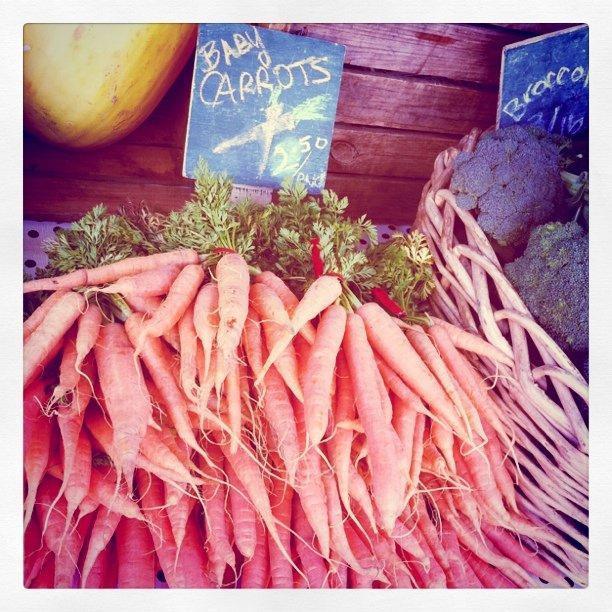How many broccolis are in the picture?
Give a very brief answer. 2. How many people are in green?
Give a very brief answer. 0. 